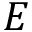Convert formula to latex. <formula><loc_0><loc_0><loc_500><loc_500>E</formula> 